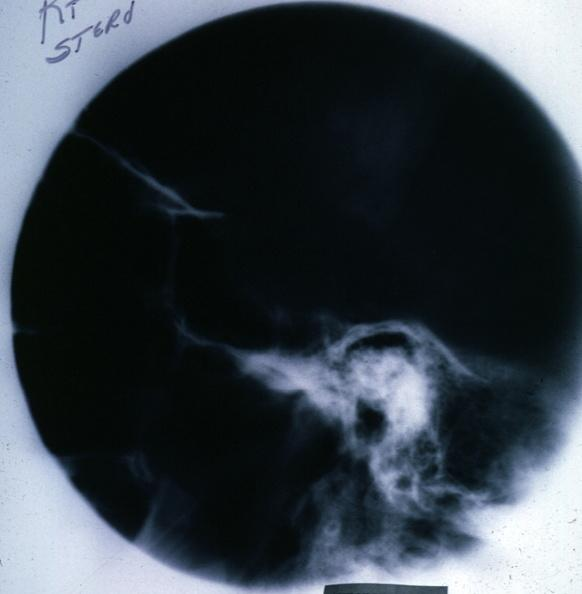does this image show x-ray sella?
Answer the question using a single word or phrase. Yes 